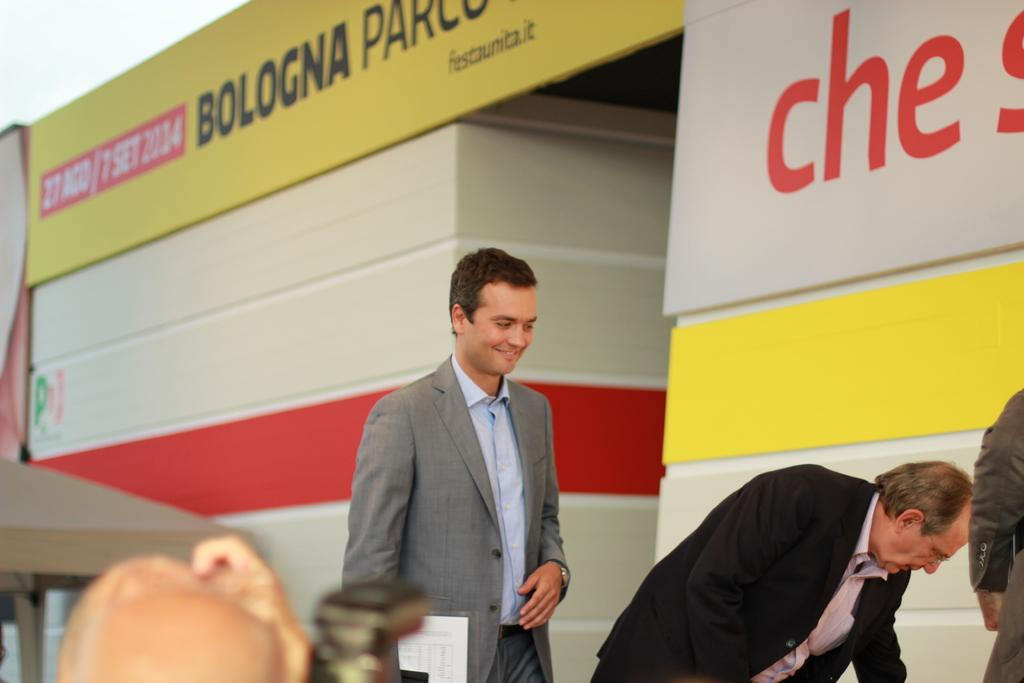How many people are in the image? There are two men in the image. What are the men wearing? Both men are wearing formal dress. Can you describe the facial expression of one of the men? One of the men is smiling. What can be seen in the background of the image? There is writing visible in the background of the image. What type of hair can be seen on the cherries in the image? There are no cherries present in the image, so there is no hair to be seen on them. 